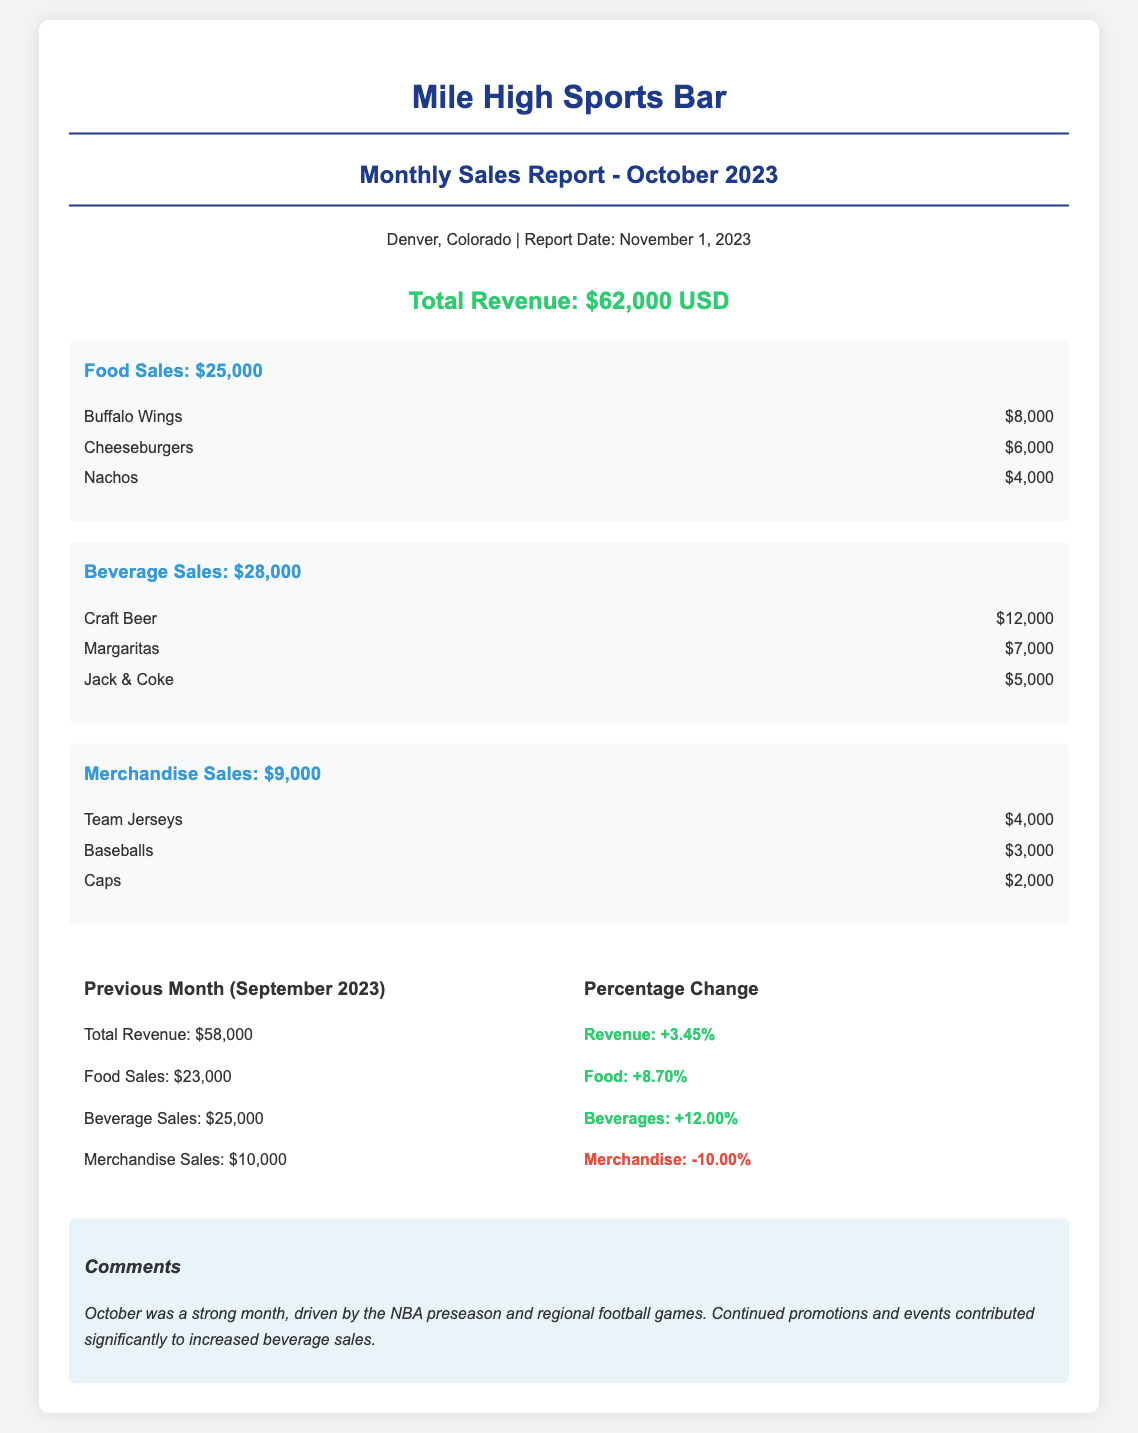What is the total revenue for October 2023? The total revenue for October 2023 is explicitly stated in the document as $62,000.
Answer: $62,000 How much did food sales generate in October 2023? The food sales total is presented as $25,000 in the document.
Answer: $25,000 What is the revenue from craft beer? The document lists craft beer sales revenue as $12,000 under beverage sales.
Answer: $12,000 What was the total revenue for September 2023? The total revenue for September 2023 is mentioned as $58,000 in the comparison section.
Answer: $58,000 What percentage change is recorded for beverage sales from September to October 2023? The percentage change for beverage sales shows an increase of 12.00% in the comparison section.
Answer: 12.00% Which category had a decrease in sales compared to September 2023? Merchandise sales showed a decline, as indicated by the -10.00% change in the document.
Answer: Merchandise What is the main reason mentioned for the sales increase in October? The comments section states that the NBA preseason and regional football games drove the increase in sales.
Answer: NBA preseason and regional football games How much did merchandise sales generate in October 2023? The document states that merchandise sales totaled $9,000 for October 2023.
Answer: $9,000 